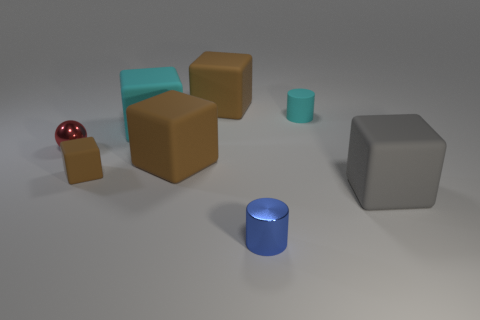There is a gray block that is the same size as the cyan cube; what is it made of?
Give a very brief answer. Rubber. What is the color of the cylinder to the right of the small cylinder that is in front of the small metal thing to the left of the large cyan matte object?
Ensure brevity in your answer.  Cyan. There is a small metallic thing on the right side of the small red thing; does it have the same shape as the big brown matte object that is behind the red object?
Provide a short and direct response. No. How many cyan cubes are there?
Your answer should be very brief. 1. What color is the rubber cylinder that is the same size as the sphere?
Provide a succinct answer. Cyan. Does the cylinder behind the small blue object have the same material as the small sphere that is in front of the small matte cylinder?
Make the answer very short. No. How big is the cyan matte thing left of the cylinder that is in front of the big gray matte block?
Offer a very short reply. Large. There is a cylinder that is behind the gray matte cube; what is it made of?
Offer a terse response. Rubber. What number of objects are objects that are in front of the small red shiny thing or brown rubber things right of the tiny matte block?
Your answer should be very brief. 5. What material is the other tiny thing that is the same shape as the tiny blue metallic object?
Provide a succinct answer. Rubber. 